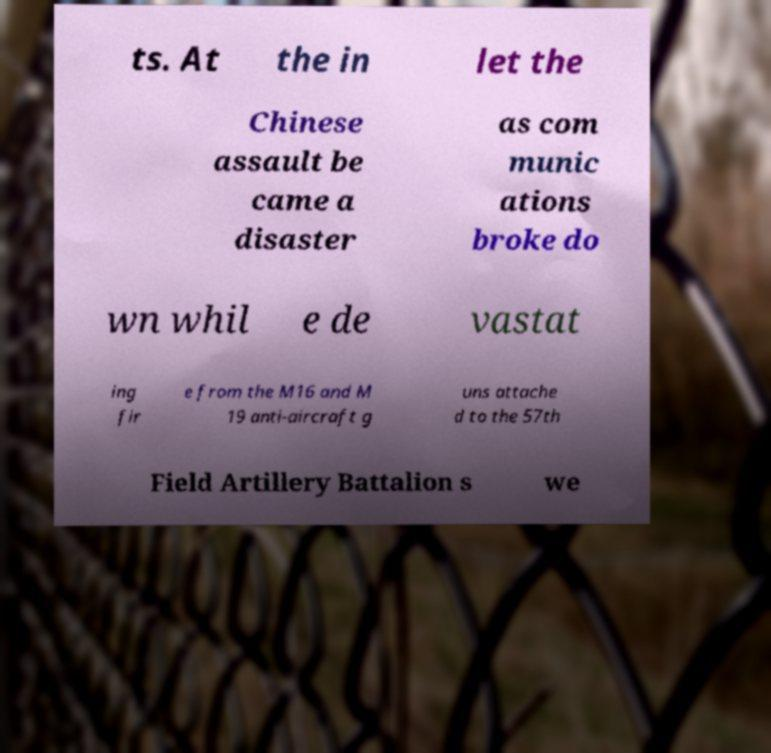What messages or text are displayed in this image? I need them in a readable, typed format. ts. At the in let the Chinese assault be came a disaster as com munic ations broke do wn whil e de vastat ing fir e from the M16 and M 19 anti-aircraft g uns attache d to the 57th Field Artillery Battalion s we 